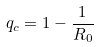Convert formula to latex. <formula><loc_0><loc_0><loc_500><loc_500>q _ { c } = 1 - \frac { 1 } { R _ { 0 } }</formula> 